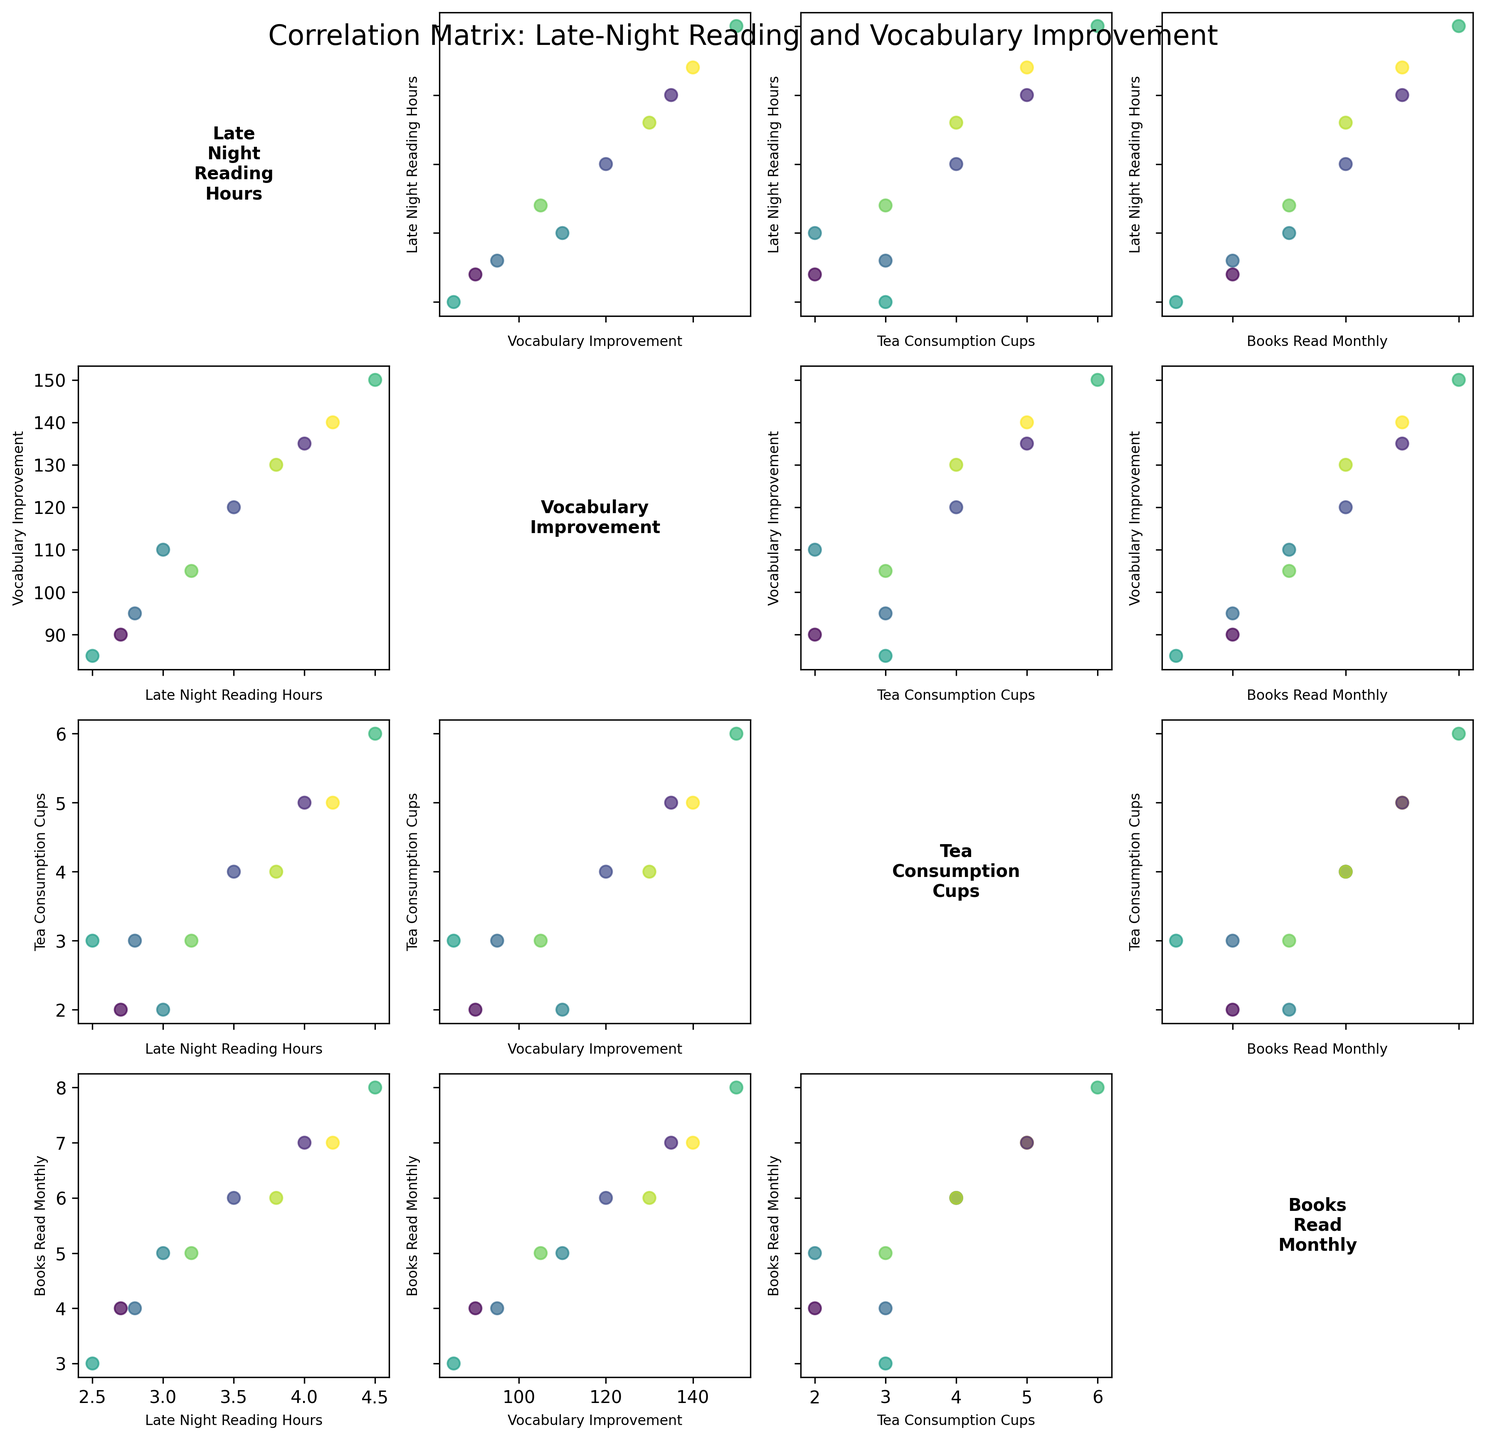What's the title of the figure? The title is usually located at the top center of the figure. The title summarizes what the plot is about.
Answer: Correlation Matrix: Late-Night Reading and Vocabulary Improvement What does the scatter plot of 'Late_Night_Reading_Hours' vs 'Vocabulary_Improvement' show? Examine the scatter plot where 'Late_Night_Reading_Hours' is on one axis and 'Vocabulary_Improvement' is on the other. Look for overall patterns or trends. A positive correlation would indicate that as one variable increases, the other tends to increase as well.
Answer: It shows a positive correlation Which language has the highest 'Vocabulary_Improvement'? Look at the data points on the axis labeled 'Vocabulary_Improvement'. Identify the highest value and check the corresponding language from the legend.
Answer: Japanese Which variables are compared in the scatter plot located in the bottom left corner? The bottom-left corner of a scatterplot matrix typically involves the last two variables listed in the dataset. Check the labels on the axes to confirm the variables being compared.
Answer: Late_Night_Reading_Hours and Books_Read_Monthly Is there a scatter plot comparing 'Tea_Consumption_Cups' and 'Books_Read_Monthly'? Locate the scatter plot matrix and identify the titles of the subplots. Find the one that lists 'Tea_Consumption_Cups' and 'Books_Read_Monthly' as its axes.
Answer: Yes, there is Compare the 'Tea_Consumption_Cups' between the languages with the highest and lowest 'Vocabulary_Improvement'. Look at the scatter plot that measures 'Tea_Consumption_Cups' and identify the points for the languages with the highest and lowest 'Vocabulary_Improvement' values, then compare their respective 'Tea_Consumption_Cups'.
Answer: Highest (Japanese): 6 cups; Lowest (Italian): 3 cups What can be inferred about 'Tea_Consumption_Cups' and 'Late_Night_Reading_Hours'? Find the scatter plot between 'Tea_Consumption_Cups' and 'Late_Night_Reading_Hours' and see if there is a discernible trend or correlation.
Answer: There appears to be a positive correlation Which two variables have the least evident direct correlation based on the scatter plots? Review all scatter plots in the matrix and look for the pair with the most scattered points without a clear trend or pattern.
Answer: Tea_Consumption_Cups and Books_Read_Monthly What is the average 'Late_Night_Reading_Hours' for all languages? Calculate the average by summing all 'Late_Night_Reading_Hours' values and dividing by the number of languages. (3.5 + 2.8 + 4.2 + 3.0 + 2.5 + 3.8 + 4.5 + 3.2 + 4.0 + 2.7) / 10
Answer: 3.42 hours Based on the scatter plots, which variable appears to be most closely related to 'Vocabulary_Improvement'? Look at the scatter plots that compare 'Vocabulary_Improvement' with other variables. Determine which scatter plot shows the strongest linear trend.
Answer: Late_Night_Reading_Hours 